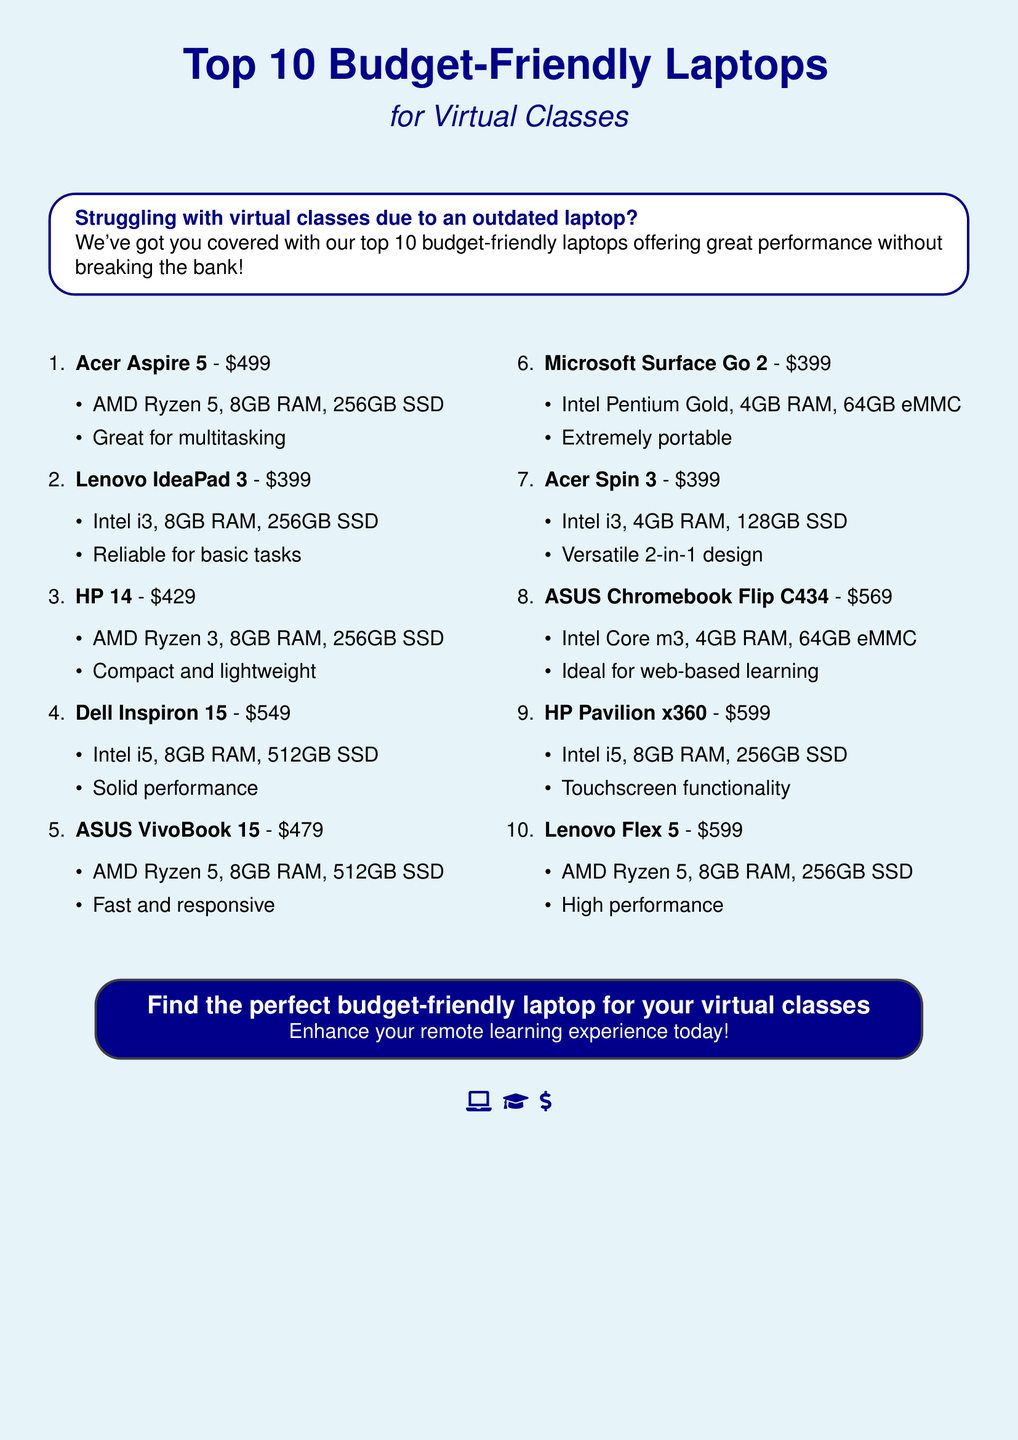What is the price of Acer Aspire 5? The price of Acer Aspire 5 is mentioned in the document as $499.
Answer: $499 How many laptops are listed in the document? The document lists a total of 10 budget-friendly laptops.
Answer: 10 Which laptop has the lowest price? The Lenovo IdeaPad 3 is identified as the lowest priced laptop in the list at $399.
Answer: $399 What kind of RAM does HP 14 have? According to the document, HP 14 is equipped with 8GB RAM.
Answer: 8GB RAM Which laptop is described as being extremely portable? The Microsoft Surface Go 2 is highlighted as the laptop that is extremely portable.
Answer: Microsoft Surface Go 2 Which two laptops are priced at $599? The HP Pavilion x360 and Lenovo Flex 5 are both priced at $599 according to the document.
Answer: HP Pavilion x360, Lenovo Flex 5 What is the main purpose highlighted for these laptops? The document emphasizes that these laptops are ideal for enhancing the experience of virtual classes.
Answer: Enhancing virtual classes Which laptop features a touchscreen? The HP Pavilion x360 is specifically noted for its touchscreen functionality.
Answer: HP Pavilion x360 What type of design does Acer Spin 3 have? The Acer Spin 3 is described as a versatile 2-in-1 design in the document.
Answer: 2-in-1 design 